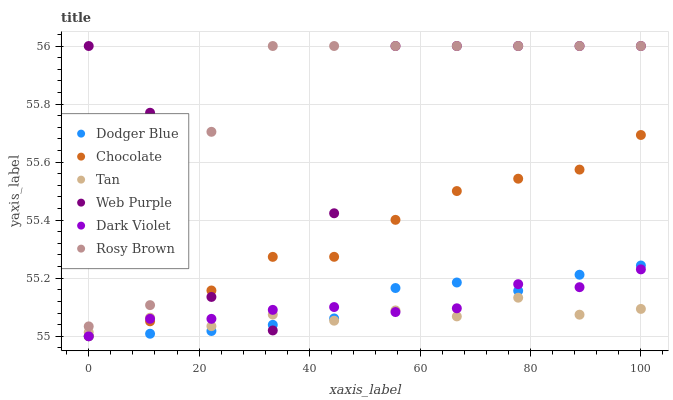Does Tan have the minimum area under the curve?
Answer yes or no. Yes. Does Rosy Brown have the maximum area under the curve?
Answer yes or no. Yes. Does Dark Violet have the minimum area under the curve?
Answer yes or no. No. Does Dark Violet have the maximum area under the curve?
Answer yes or no. No. Is Dodger Blue the smoothest?
Answer yes or no. Yes. Is Web Purple the roughest?
Answer yes or no. Yes. Is Dark Violet the smoothest?
Answer yes or no. No. Is Dark Violet the roughest?
Answer yes or no. No. Does Dark Violet have the lowest value?
Answer yes or no. Yes. Does Web Purple have the lowest value?
Answer yes or no. No. Does Web Purple have the highest value?
Answer yes or no. Yes. Does Dark Violet have the highest value?
Answer yes or no. No. Is Chocolate less than Rosy Brown?
Answer yes or no. Yes. Is Rosy Brown greater than Tan?
Answer yes or no. Yes. Does Dodger Blue intersect Dark Violet?
Answer yes or no. Yes. Is Dodger Blue less than Dark Violet?
Answer yes or no. No. Is Dodger Blue greater than Dark Violet?
Answer yes or no. No. Does Chocolate intersect Rosy Brown?
Answer yes or no. No. 